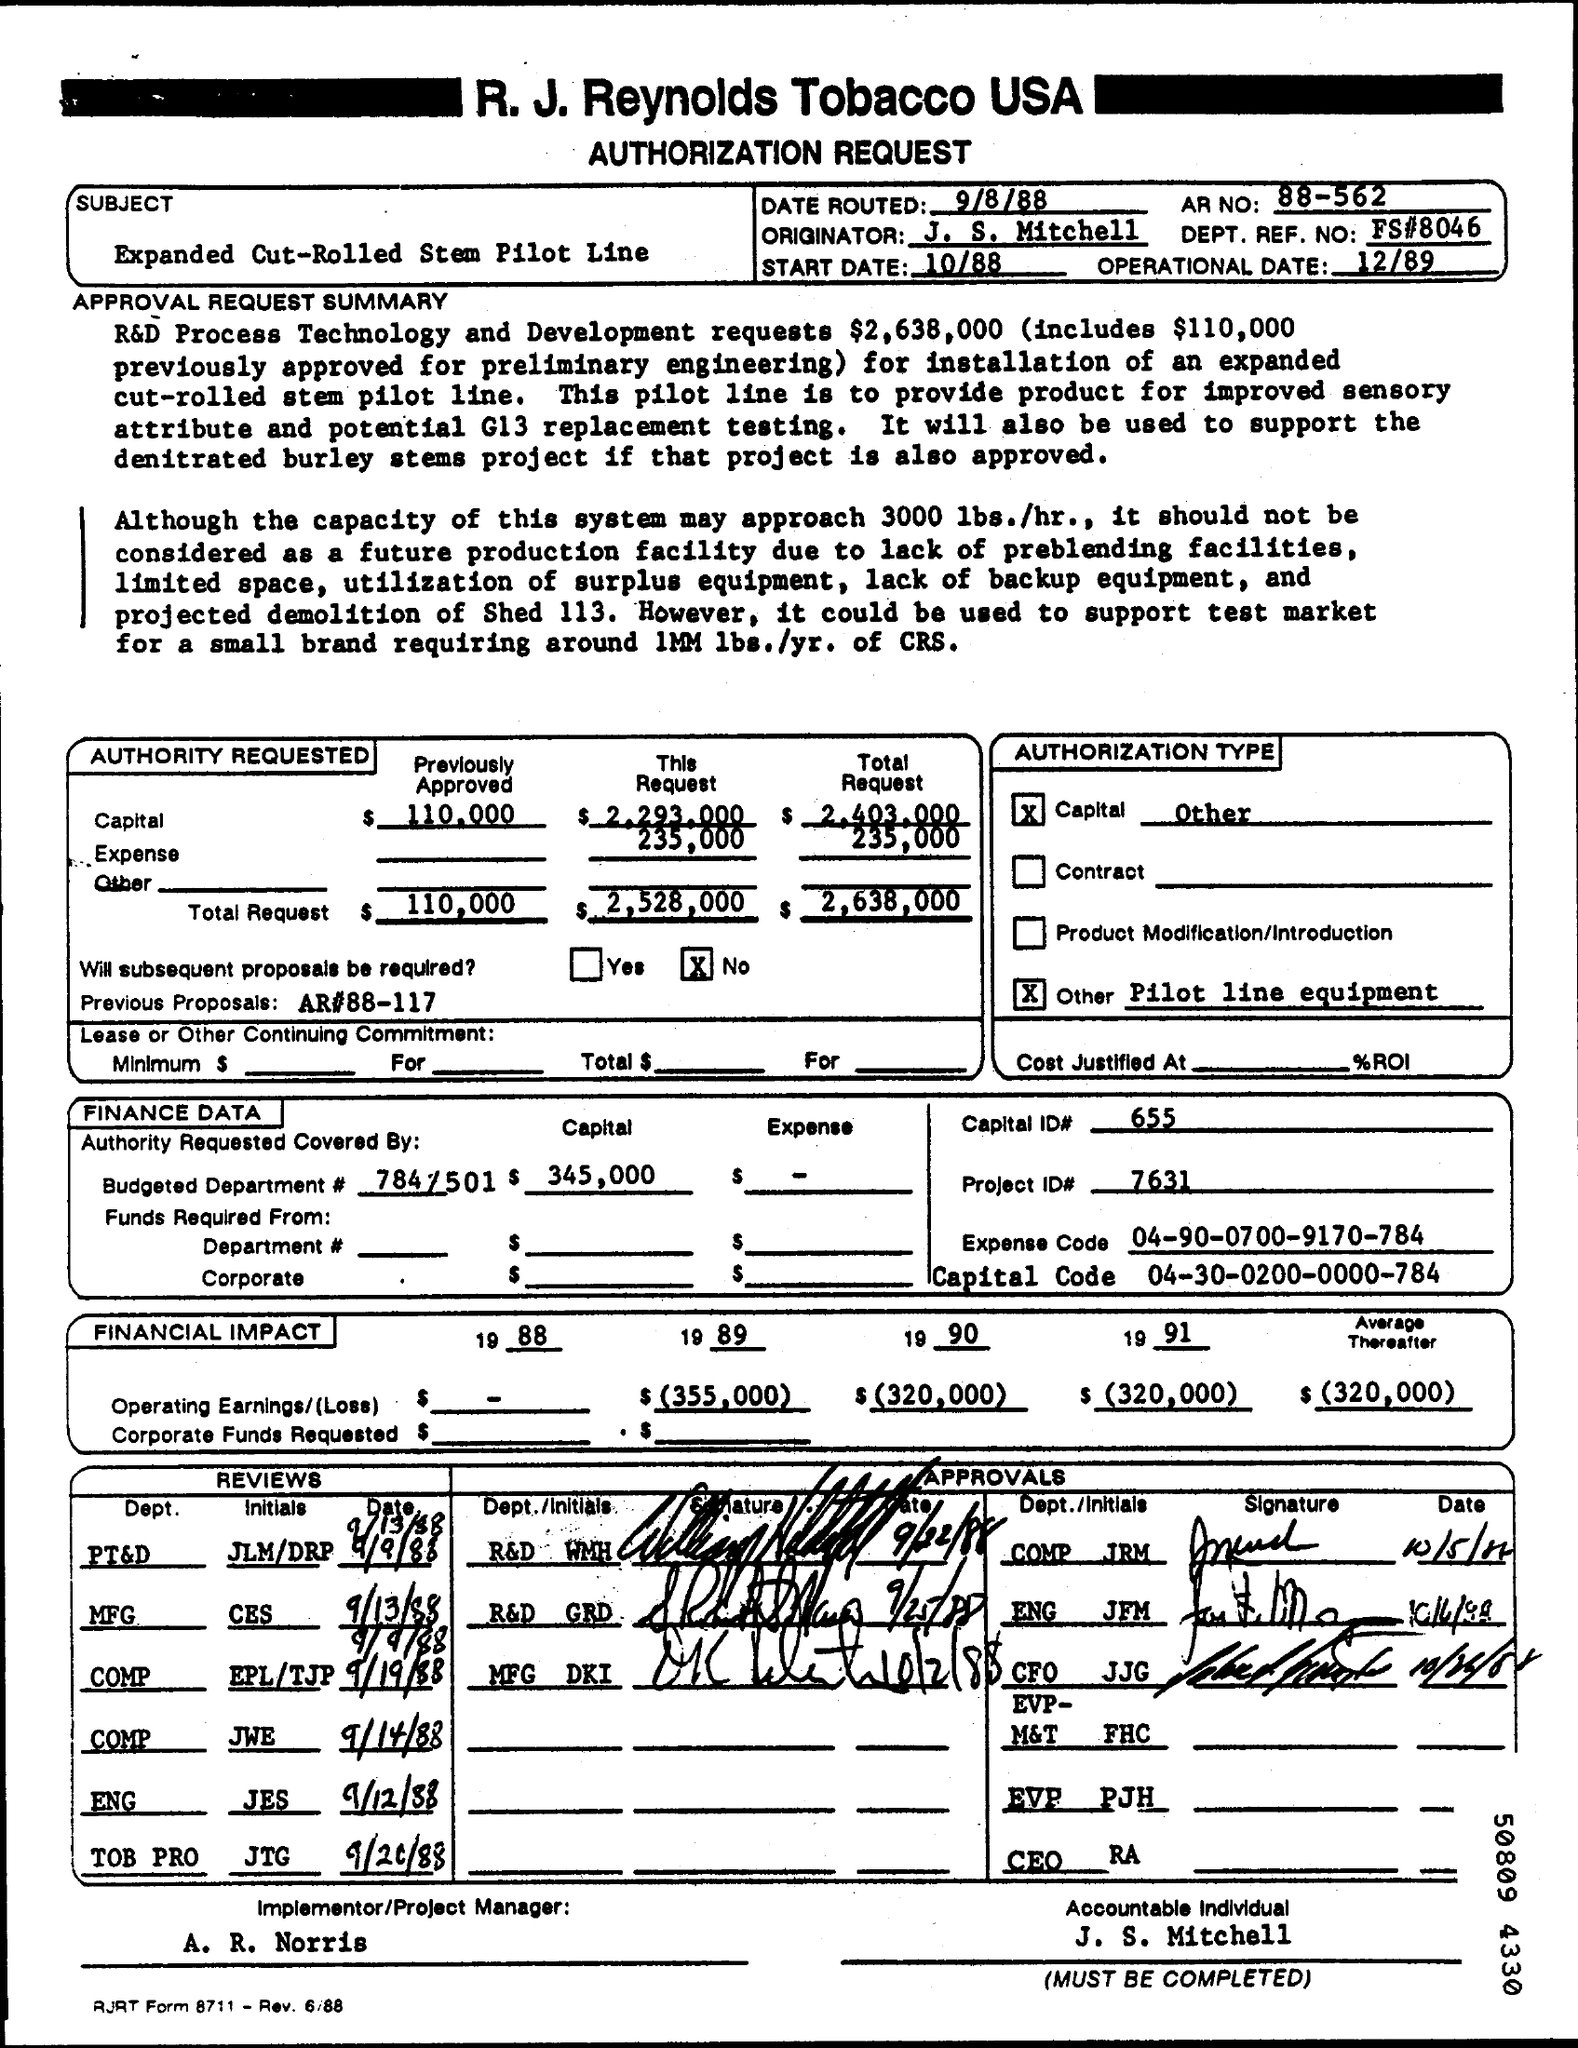Who is accountable individual?
Offer a very short reply. J. S. Mitchell. What is total requirement for R&D process technology and development?
Your response must be concise. $2,638,000. What was the previous approved amount for preliminary engineering?
Your answer should be compact. $ 110,000. 